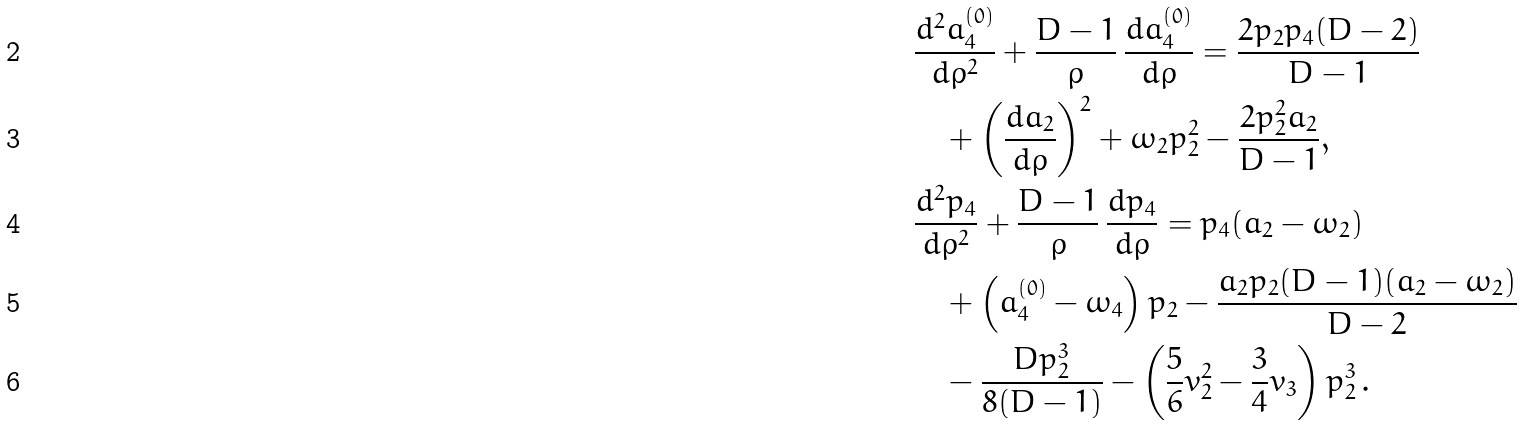Convert formula to latex. <formula><loc_0><loc_0><loc_500><loc_500>& \frac { d ^ { 2 } a _ { 4 } ^ { ( 0 ) } } { d \rho ^ { 2 } } + \frac { D - 1 } { \rho } \, \frac { d a _ { 4 } ^ { ( 0 ) } } { d \rho } = \frac { 2 p _ { 2 } p _ { 4 } ( D - 2 ) } { D - 1 } \\ & \quad + \left ( \frac { d a _ { 2 } } { d \rho } \right ) ^ { 2 } + \omega _ { 2 } p _ { 2 } ^ { 2 } - \frac { 2 p _ { 2 } ^ { 2 } a _ { 2 } } { D - 1 } , \\ & \frac { d ^ { 2 } p _ { 4 } } { d \rho ^ { 2 } } + \frac { D - 1 } { \rho } \, \frac { d p _ { 4 } } { d \rho } = p _ { 4 } ( a _ { 2 } - \omega _ { 2 } ) \\ & \quad + \left ( a _ { 4 } ^ { ( 0 ) } - \omega _ { 4 } \right ) p _ { 2 } - \frac { a _ { 2 } p _ { 2 } ( D - 1 ) ( a _ { 2 } - \omega _ { 2 } ) } { D - 2 } \\ & \quad - \frac { D p _ { 2 } ^ { 3 } } { 8 ( D - 1 ) } - \left ( \frac { 5 } { 6 } v _ { 2 } ^ { 2 } - \frac { 3 } { 4 } v _ { 3 } \right ) p _ { 2 } ^ { 3 } \, .</formula> 